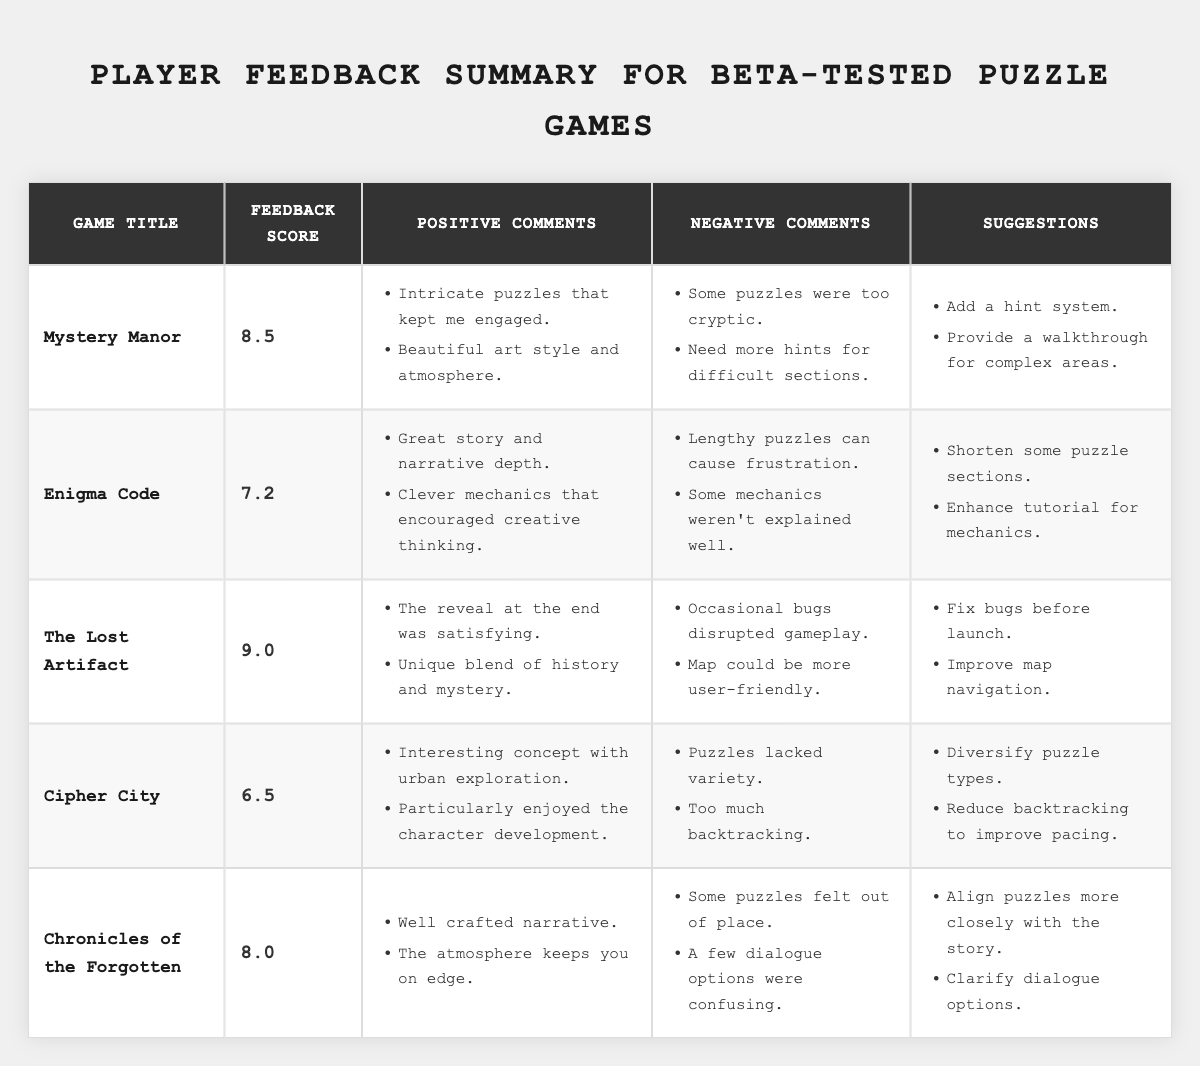What is the feedback score for "Enigma Code"? The feedback score can be directly retrieved from the table under "Enigma Code," which shows a score of 7.2.
Answer: 7.2 Which game has the highest feedback score? By comparing the scores listed in the table, "The Lost Artifact" has the highest score at 9.0.
Answer: The Lost Artifact How many negative comments did "Cipher City" receive? The "negative comments" section for "Cipher City" contains two comments listed under it.
Answer: 2 What is the average feedback score of the games listed? The scores for the games are 8.5, 7.2, 9.0, 6.5, and 8.0. The sum is (8.5 + 7.2 + 9.0 + 6.5 + 8.0) = 39.2 and there are 5 games, so the average score is 39.2 / 5 = 7.84.
Answer: 7.84 True or False: "Mystery Manor" received positive feedback regarding its puzzles. The table lists several positive comments about "Mystery Manor," specifically highlighting "Intricate puzzles that kept me engaged," confirming the statement is true.
Answer: True How many suggestions were made for improvements to "The Lost Artifact"? The suggestions for "The Lost Artifact" section lists two suggestions: "Fix bugs before launch" and "Improve map navigation."
Answer: 2 Which game had feedback mentioning the need for a hint system? The suggestions for "Mystery Manor" include "Add a hint system," indicating that this game received feedback regarding this need.
Answer: Mystery Manor What do players think about the atmosphere of "Chronicles of the Forgotten"? The feedback includes a positive comment stating, "The atmosphere keeps you on edge," suggesting that players appreciate it.
Answer: Positive feedback What is a common criticism for the game "Enigma Code"? Under "negative comments," it states, "Lengthy puzzles can cause frustration," indicating a common criticism from players.
Answer: Lengthy puzzles cause frustration Which game suggested improvements to map navigation? The table lists "Improve map navigation" as a suggestion under "The Lost Artifact," identifying this game as needing map navigation improvements.
Answer: The Lost Artifact 